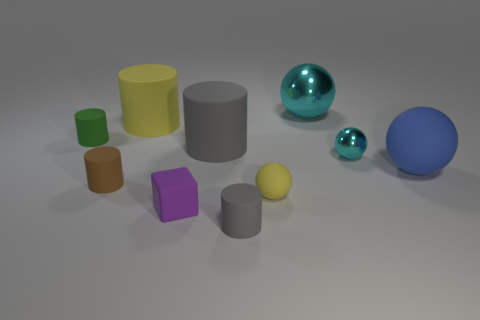Which objects in the image could float in water? Based on the image, it's not possible to determine the exact materials of the objects; however, if we assume they are made from typical materials, the small yellow sphere and possibly the small green cylinder could float if they are made of a lightweight material such as plastic. 